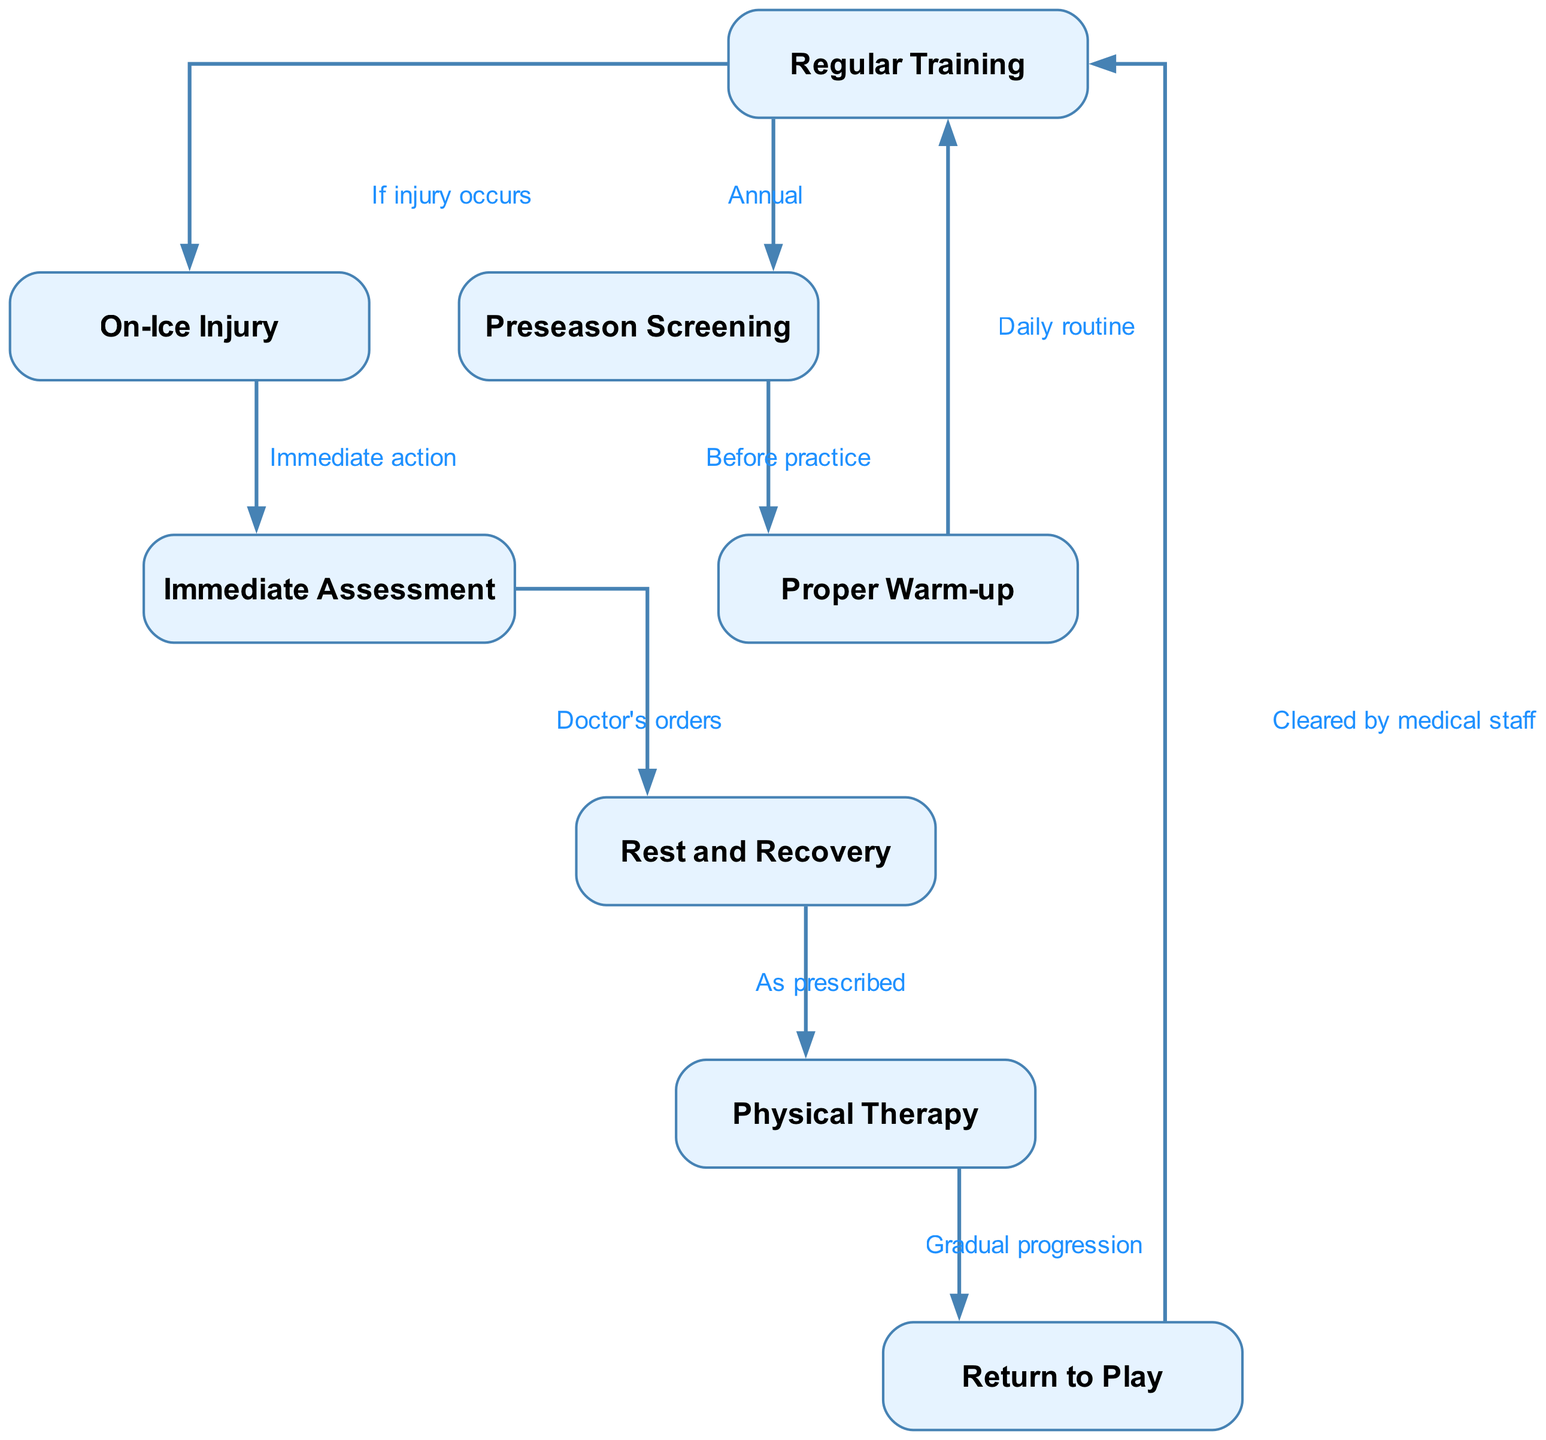What is the first step in the workflow? The diagram shows that the very first step in the workflow is "Regular Training," indicated as the initial node in the flow chart.
Answer: Regular Training How many nodes are there in the diagram? By counting the nodes listed in the diagram's data, we find there are a total of 8 distinct nodes, each representing key steps in the injury prevention and recovery workflow.
Answer: 8 Which step follows "Immediate Assessment"? Following the "Immediate Assessment," the next step indicated in the flow chart is "Rest and Recovery," which directly connects to it.
Answer: Rest and Recovery What action is taken if an injury occurs during training? The diagram specifies that if an injury occurs during training, the next action is to proceed to "On-Ice Injury," which is clearly marked as the outcome of that situation.
Answer: On-Ice Injury What is required before "Return to Play"? The diagram outlines that "Return to Play" happens only after receiving clearance from medical staff, as indicated by the connecting edge from "Return to Play" to "Regular Training."
Answer: Cleared by medical staff How does one progress from "Physical Therapy" to "Return to Play"? The connection from "Physical Therapy" to "Return to Play" shows that the progression happens through "Gradual progression," meaning athletes must gradually regain their readiness before returning to play.
Answer: Gradual progression How often does "Preseason Screening" occur? According to the flow chart, the "Preseason Screening" occurs annually, as specified by the edge connecting “Regular Training” to “Preseason Screening.”
Answer: Annual What step supports the athletes' recovery according to medical advice? The diagram indicates that "Physical Therapy" is the step that supports recovery according to the doctor's orders, connecting "Rest and Recovery" to "Physical Therapy."
Answer: Physical Therapy What happens after "Proper Warm-up"? The flow chart indicates that after "Proper Warm-up," athletes return to "Regular Training," emphasizing it as a daily routine to maintain fitness and prevent injuries.
Answer: Regular Training 